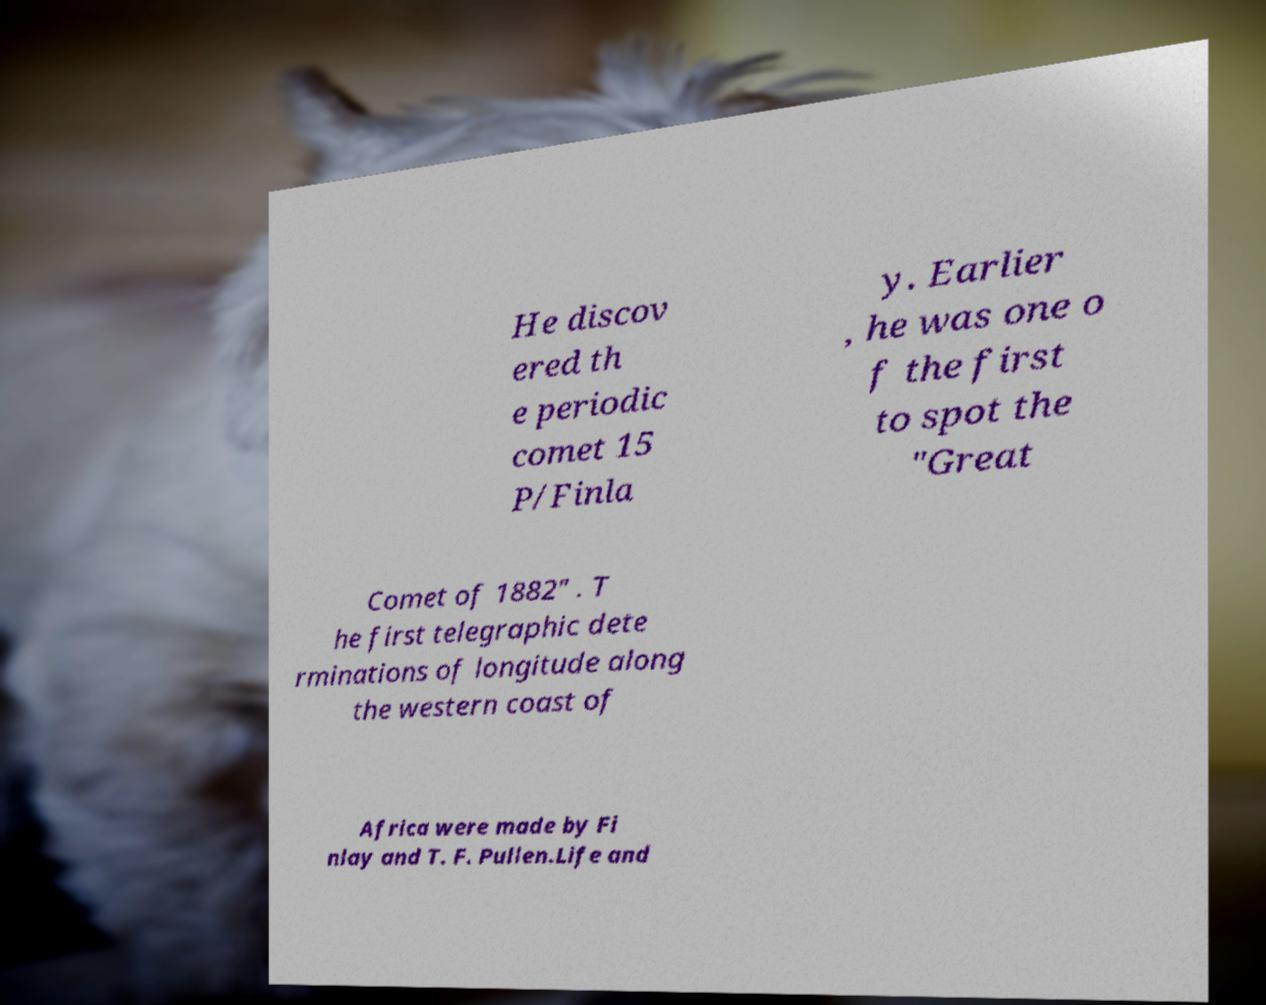Please read and relay the text visible in this image. What does it say? He discov ered th e periodic comet 15 P/Finla y. Earlier , he was one o f the first to spot the "Great Comet of 1882" . T he first telegraphic dete rminations of longitude along the western coast of Africa were made by Fi nlay and T. F. Pullen.Life and 